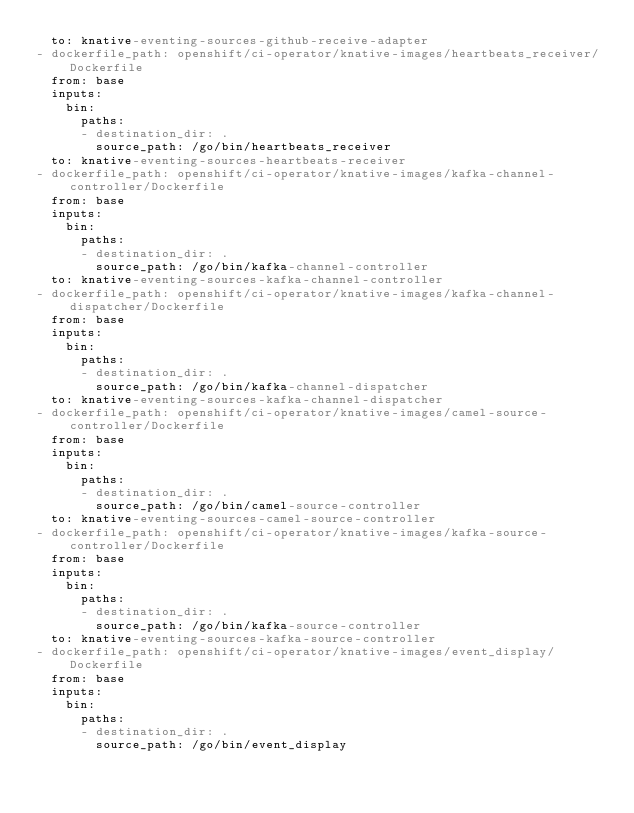<code> <loc_0><loc_0><loc_500><loc_500><_YAML_>  to: knative-eventing-sources-github-receive-adapter
- dockerfile_path: openshift/ci-operator/knative-images/heartbeats_receiver/Dockerfile
  from: base
  inputs:
    bin:
      paths:
      - destination_dir: .
        source_path: /go/bin/heartbeats_receiver
  to: knative-eventing-sources-heartbeats-receiver
- dockerfile_path: openshift/ci-operator/knative-images/kafka-channel-controller/Dockerfile
  from: base
  inputs:
    bin:
      paths:
      - destination_dir: .
        source_path: /go/bin/kafka-channel-controller
  to: knative-eventing-sources-kafka-channel-controller
- dockerfile_path: openshift/ci-operator/knative-images/kafka-channel-dispatcher/Dockerfile
  from: base
  inputs:
    bin:
      paths:
      - destination_dir: .
        source_path: /go/bin/kafka-channel-dispatcher
  to: knative-eventing-sources-kafka-channel-dispatcher
- dockerfile_path: openshift/ci-operator/knative-images/camel-source-controller/Dockerfile
  from: base
  inputs:
    bin:
      paths:
      - destination_dir: .
        source_path: /go/bin/camel-source-controller
  to: knative-eventing-sources-camel-source-controller
- dockerfile_path: openshift/ci-operator/knative-images/kafka-source-controller/Dockerfile
  from: base
  inputs:
    bin:
      paths:
      - destination_dir: .
        source_path: /go/bin/kafka-source-controller
  to: knative-eventing-sources-kafka-source-controller
- dockerfile_path: openshift/ci-operator/knative-images/event_display/Dockerfile
  from: base
  inputs:
    bin:
      paths:
      - destination_dir: .
        source_path: /go/bin/event_display</code> 